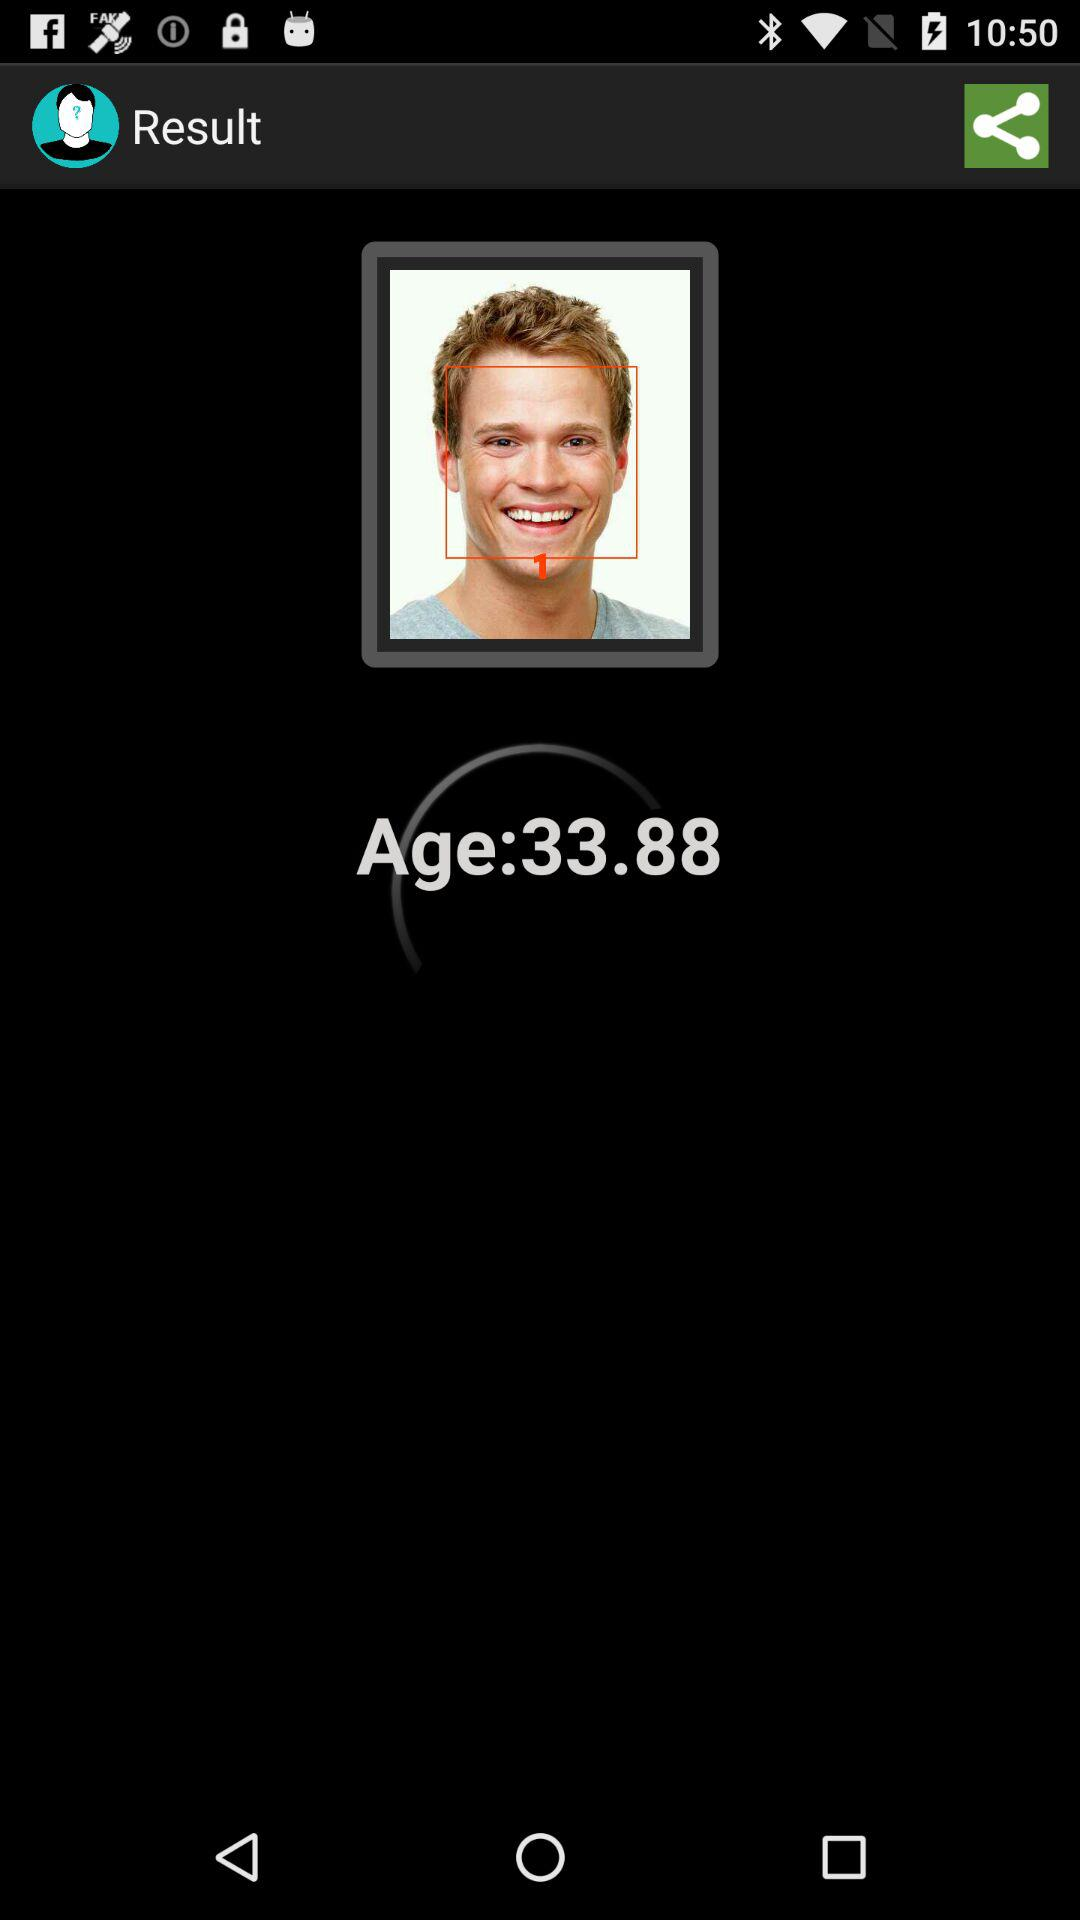What is the age? The age is 33.88. 